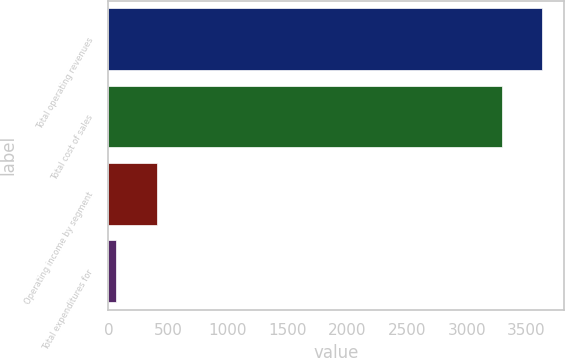Convert chart to OTSL. <chart><loc_0><loc_0><loc_500><loc_500><bar_chart><fcel>Total operating revenues<fcel>Total cost of sales<fcel>Operating income by segment<fcel>Total expenditures for<nl><fcel>3628.7<fcel>3292<fcel>403.7<fcel>67<nl></chart> 